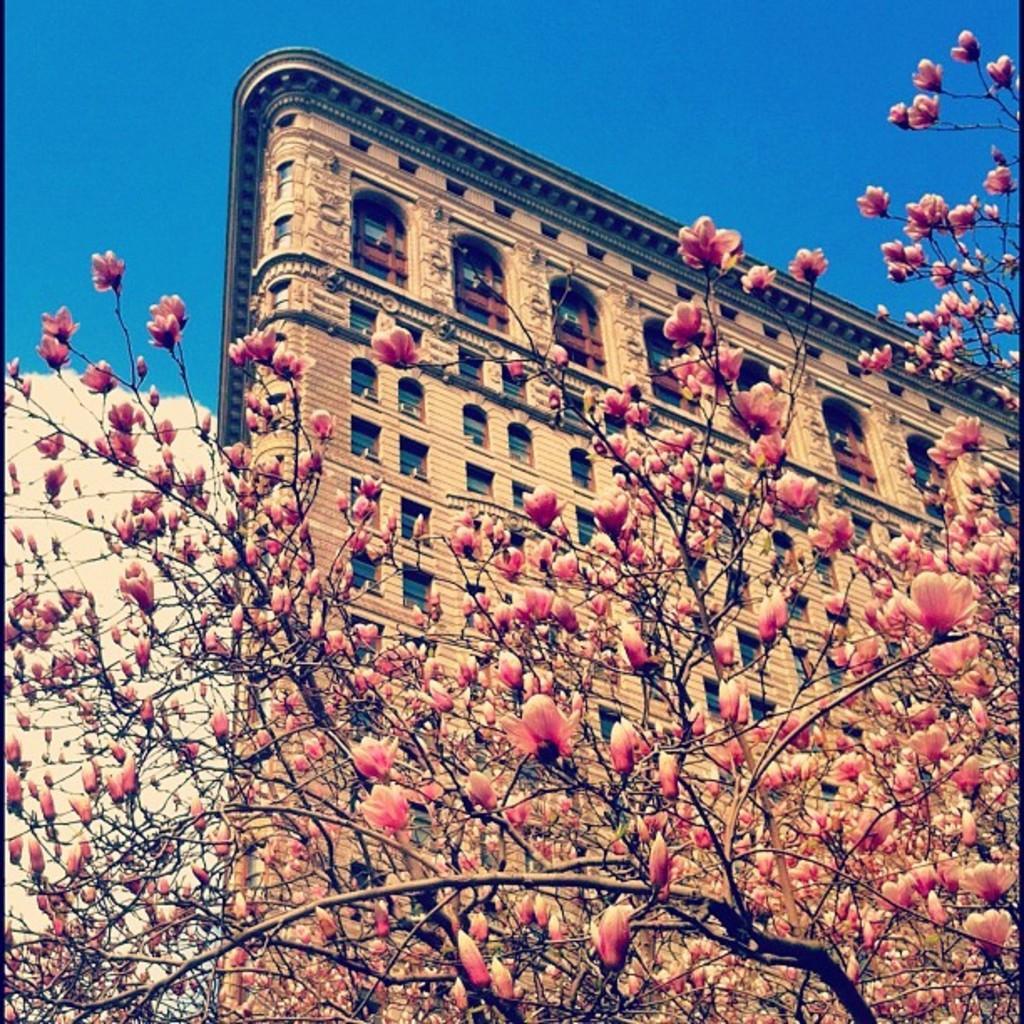In one or two sentences, can you explain what this image depicts? In this image in front there is a tree. In the background of the image there is a building and sky. 